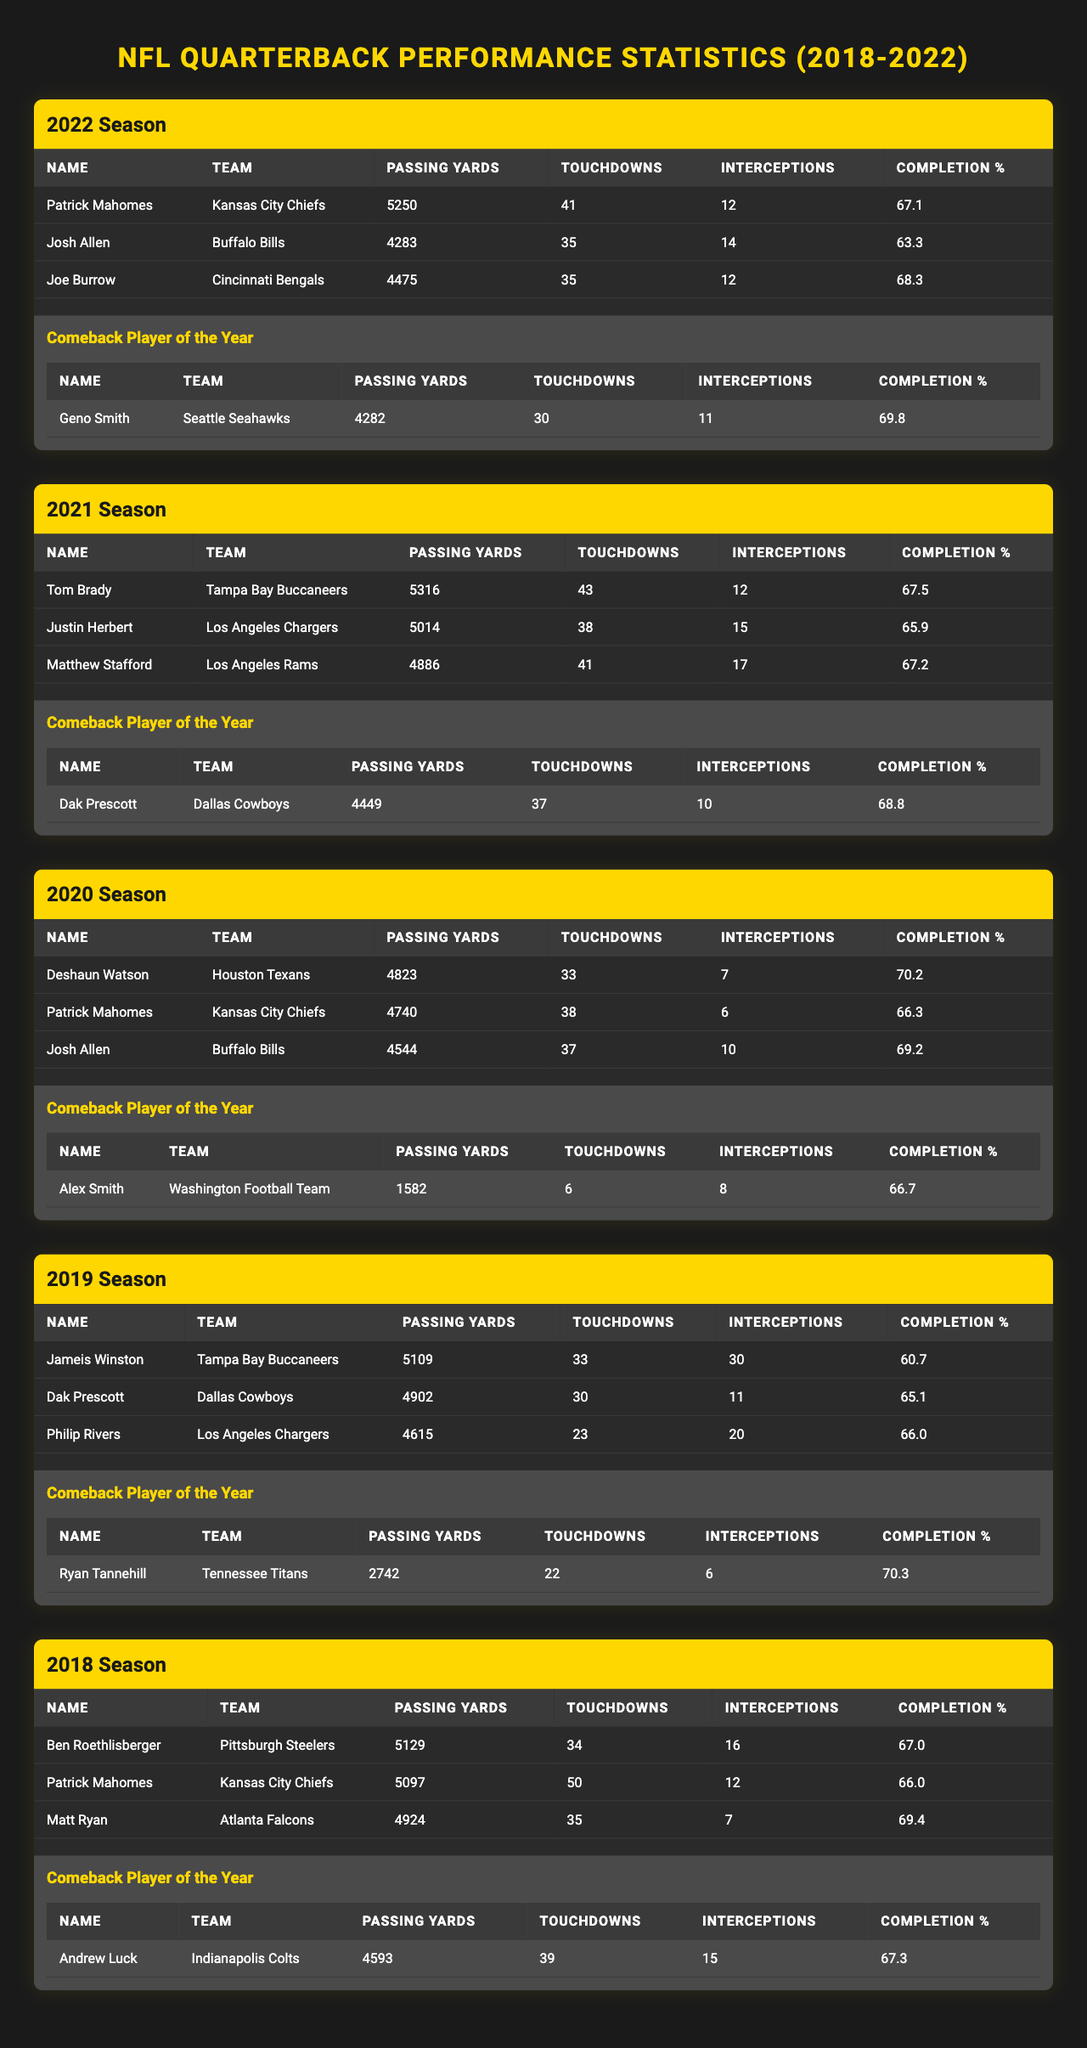What is the highest number of passing yards achieved by a quarterback from 2018 to 2022? In the 2018 season, Patrick Mahomes achieved 5097 passing yards, which is the highest across the seasons listed in the table compared to other top performers in each season.
Answer: 5316 Who had the most touchdowns in the 2021 season? Tom Brady had the highest number of touchdowns in the 2021 season with 43 touchdowns, surpassing other top performers listed that year.
Answer: 43 What is the average completion percentage of the top three quarterbacks in 2020? The completion percentages of the top three quarterbacks in 2020 are 70.2, 66.3, and 69.2. The average is (70.2 + 66.3 + 69.2) / 3 = 68.57.
Answer: 68.57 Did any quarterback have more than 30 interceptions in a season from 2018 to 2022? In the 2019 season, Jameis Winston had 30 interceptions, which is indeed more than 30.
Answer: Yes Which quarterback had the highest passing yards in a losing season among the comeback players? Comparing the comeback players: Geno Smith had 4282 passing yards in 2022, Dak Prescott had 4449 in 2021, Alex Smith had 1582 in 2020, Ryan Tannehill had 2742 in 2019, and Andrew Luck had 4593 in 2018. Dak Prescott had the highest passing yards among them, despite facing challenges.
Answer: 4449 Was there a season where the top performer also became the Comeback Player of the Year? No, after reviewing each season, no player listed as a top performer was also recognized as the Comeback Player of the Year during the same season.
Answer: No What was the total number of touchdowns by the top performers in the 2022 season? In 2022, the touchdowns by top performers are 41 (Patrick Mahomes) + 35 (Josh Allen) + 35 (Joe Burrow) = 111.
Answer: 111 Identify the quarterback with the highest completion percentage in 2019 among the top performers. For 2019, the completion percentages are 60.7 (Jameis Winston), 65.1 (Dak Prescott), and 66.0 (Philip Rivers). The highest is Philip Rivers with 66.0%.
Answer: 66.0 What is the difference in passing yards between the Comeback Player of 2021 and the Comeback Player of 2022? The passing yards for 2021's Comeback Player (Dak Prescott) is 4449 and for 2022's Comeback Player (Geno Smith) is 4282. The difference is 4449 - 4282 = 167 yards.
Answer: 167 How many touchdowns did the 2020 Comeback Player throw compared to the 2019 Comeback Player? The 2020 Comeback Player, Alex Smith, threw 6 touchdowns, while the 2019 Comeback Player, Ryan Tannehill, threw 22. The comparison shows Tannehill threw 16 more touchdowns.
Answer: 16 more 